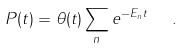Convert formula to latex. <formula><loc_0><loc_0><loc_500><loc_500>P ( t ) = \theta ( t ) \sum _ { n } e ^ { - E _ { n } t } \ \ .</formula> 